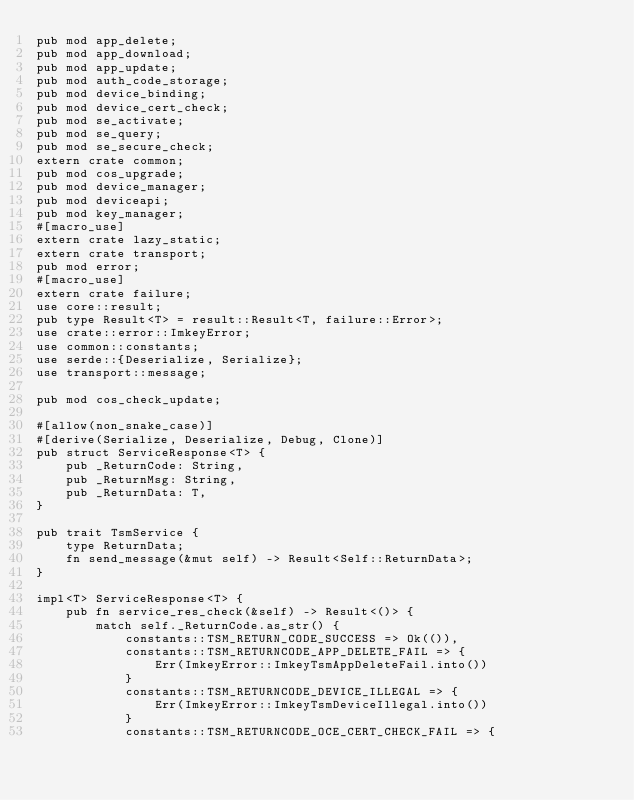<code> <loc_0><loc_0><loc_500><loc_500><_Rust_>pub mod app_delete;
pub mod app_download;
pub mod app_update;
pub mod auth_code_storage;
pub mod device_binding;
pub mod device_cert_check;
pub mod se_activate;
pub mod se_query;
pub mod se_secure_check;
extern crate common;
pub mod cos_upgrade;
pub mod device_manager;
pub mod deviceapi;
pub mod key_manager;
#[macro_use]
extern crate lazy_static;
extern crate transport;
pub mod error;
#[macro_use]
extern crate failure;
use core::result;
pub type Result<T> = result::Result<T, failure::Error>;
use crate::error::ImkeyError;
use common::constants;
use serde::{Deserialize, Serialize};
use transport::message;

pub mod cos_check_update;

#[allow(non_snake_case)]
#[derive(Serialize, Deserialize, Debug, Clone)]
pub struct ServiceResponse<T> {
    pub _ReturnCode: String,
    pub _ReturnMsg: String,
    pub _ReturnData: T,
}

pub trait TsmService {
    type ReturnData;
    fn send_message(&mut self) -> Result<Self::ReturnData>;
}

impl<T> ServiceResponse<T> {
    pub fn service_res_check(&self) -> Result<()> {
        match self._ReturnCode.as_str() {
            constants::TSM_RETURN_CODE_SUCCESS => Ok(()),
            constants::TSM_RETURNCODE_APP_DELETE_FAIL => {
                Err(ImkeyError::ImkeyTsmAppDeleteFail.into())
            }
            constants::TSM_RETURNCODE_DEVICE_ILLEGAL => {
                Err(ImkeyError::ImkeyTsmDeviceIllegal.into())
            }
            constants::TSM_RETURNCODE_OCE_CERT_CHECK_FAIL => {</code> 